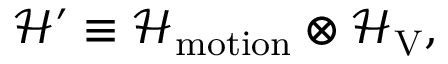Convert formula to latex. <formula><loc_0><loc_0><loc_500><loc_500>\mathcal { H } ^ { \prime } \equiv \mathcal { H } _ { m o t i o n } \otimes \mathcal { H } _ { V } ,</formula> 